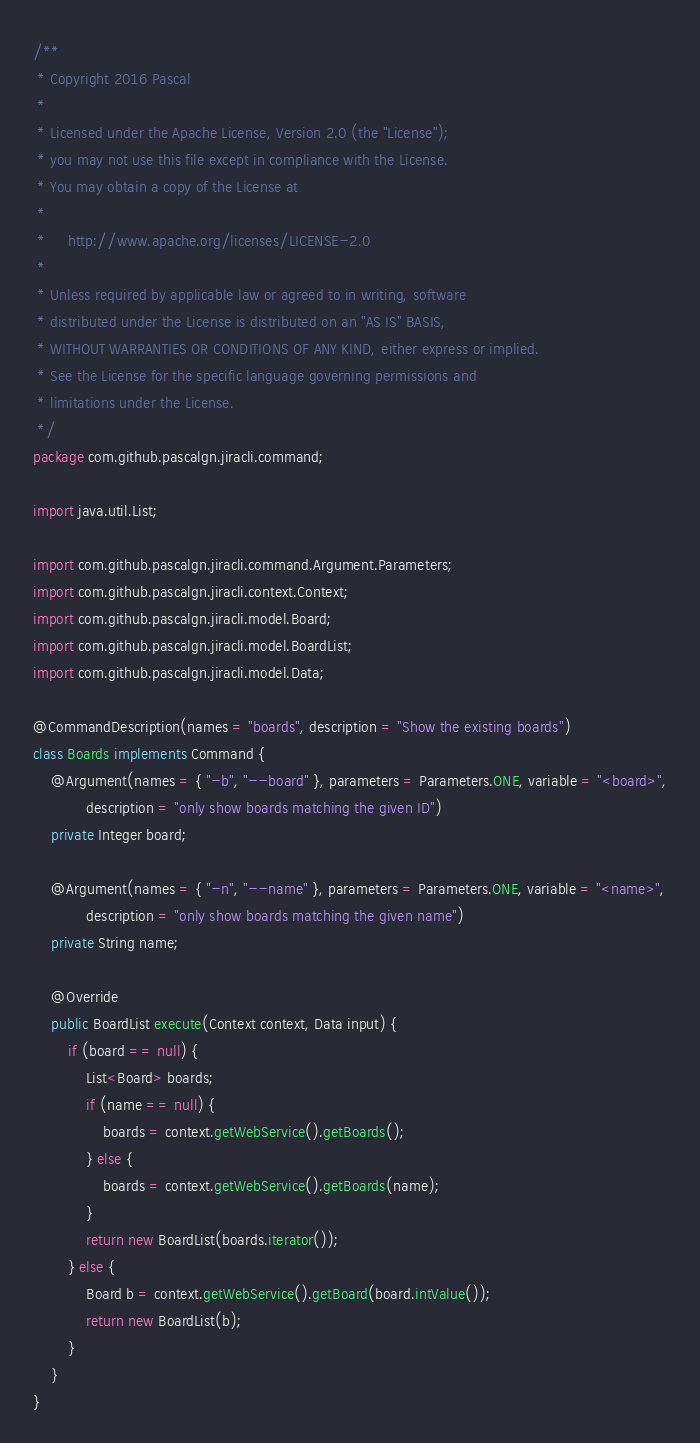Convert code to text. <code><loc_0><loc_0><loc_500><loc_500><_Java_>/**
 * Copyright 2016 Pascal
 *
 * Licensed under the Apache License, Version 2.0 (the "License");
 * you may not use this file except in compliance with the License.
 * You may obtain a copy of the License at
 *
 *     http://www.apache.org/licenses/LICENSE-2.0
 *
 * Unless required by applicable law or agreed to in writing, software
 * distributed under the License is distributed on an "AS IS" BASIS,
 * WITHOUT WARRANTIES OR CONDITIONS OF ANY KIND, either express or implied.
 * See the License for the specific language governing permissions and
 * limitations under the License.
 */
package com.github.pascalgn.jiracli.command;

import java.util.List;

import com.github.pascalgn.jiracli.command.Argument.Parameters;
import com.github.pascalgn.jiracli.context.Context;
import com.github.pascalgn.jiracli.model.Board;
import com.github.pascalgn.jiracli.model.BoardList;
import com.github.pascalgn.jiracli.model.Data;

@CommandDescription(names = "boards", description = "Show the existing boards")
class Boards implements Command {
    @Argument(names = { "-b", "--board" }, parameters = Parameters.ONE, variable = "<board>",
            description = "only show boards matching the given ID")
    private Integer board;

    @Argument(names = { "-n", "--name" }, parameters = Parameters.ONE, variable = "<name>",
            description = "only show boards matching the given name")
    private String name;

    @Override
    public BoardList execute(Context context, Data input) {
        if (board == null) {
            List<Board> boards;
            if (name == null) {
                boards = context.getWebService().getBoards();
            } else {
                boards = context.getWebService().getBoards(name);
            }
            return new BoardList(boards.iterator());
        } else {
            Board b = context.getWebService().getBoard(board.intValue());
            return new BoardList(b);
        }
    }
}
</code> 